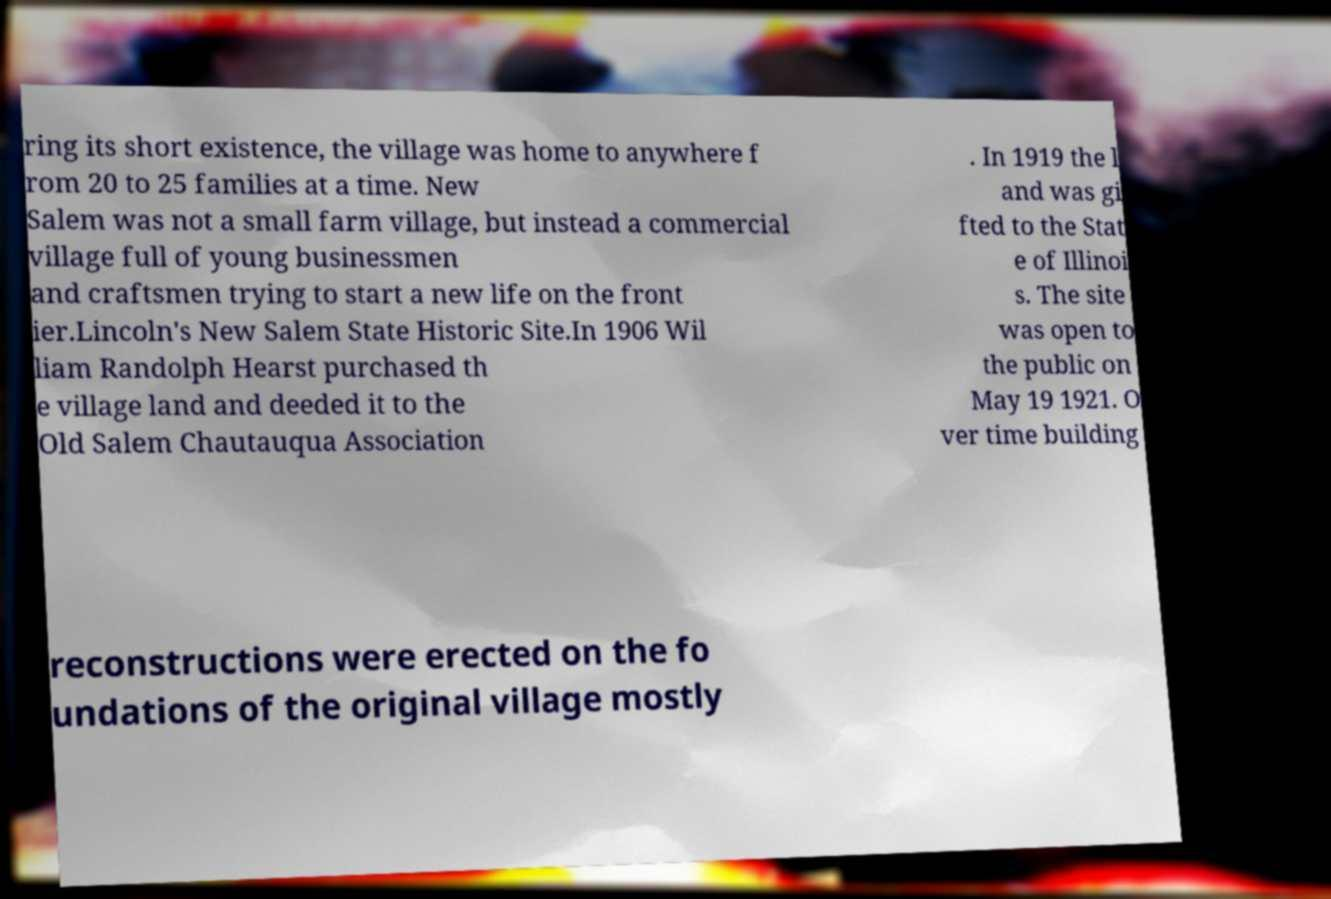Please read and relay the text visible in this image. What does it say? ring its short existence, the village was home to anywhere f rom 20 to 25 families at a time. New Salem was not a small farm village, but instead a commercial village full of young businessmen and craftsmen trying to start a new life on the front ier.Lincoln's New Salem State Historic Site.In 1906 Wil liam Randolph Hearst purchased th e village land and deeded it to the Old Salem Chautauqua Association . In 1919 the l and was gi fted to the Stat e of Illinoi s. The site was open to the public on May 19 1921. O ver time building reconstructions were erected on the fo undations of the original village mostly 